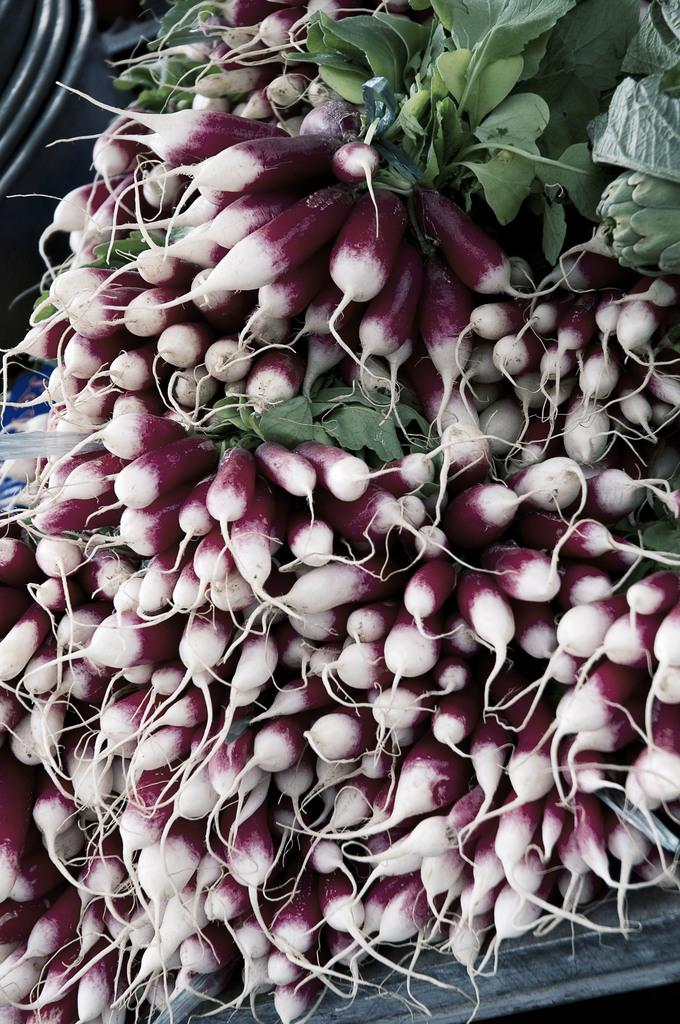What type of vegetable is featured in the image? There are bunches of beetroots in the image. What part of the beetroots is visible? The beetroots have leaves. Where are the beetroots located in the image? The beetroots are on a table at the bottom of the image. What type of pancake is being served on the table in the image? There is no pancake present in the image; it features bunches of beetroots on a table. What type of meat is visible in the image? There is no meat visible in the image; it features bunches of beetroots on a table. 